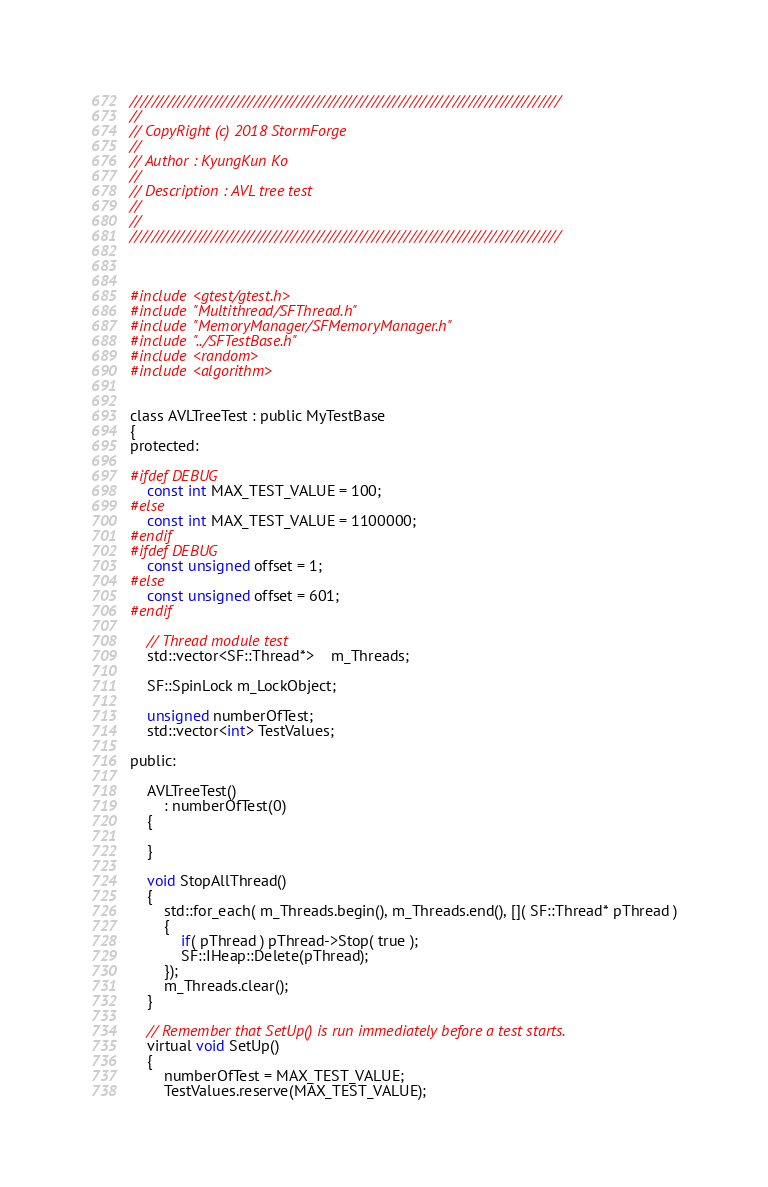<code> <loc_0><loc_0><loc_500><loc_500><_C_>////////////////////////////////////////////////////////////////////////////////
// 
// CopyRight (c) 2018 StormForge
// 
// Author : KyungKun Ko
//
// Description : AVL tree test
//	
//
////////////////////////////////////////////////////////////////////////////////



#include <gtest/gtest.h>
#include "Multithread/SFThread.h"
#include "MemoryManager/SFMemoryManager.h"
#include "../SFTestBase.h"
#include <random>
#include <algorithm>


class AVLTreeTest : public MyTestBase
{
protected:

#ifdef DEBUG
	const int MAX_TEST_VALUE = 100;
#else
	const int MAX_TEST_VALUE = 1100000;
#endif
#ifdef DEBUG
	const unsigned offset = 1;
#else
	const unsigned offset = 601;
#endif

	// Thread module test
	std::vector<SF::Thread*>	m_Threads;

	SF::SpinLock m_LockObject;

	unsigned numberOfTest;
	std::vector<int> TestValues;

public:

	AVLTreeTest()
		: numberOfTest(0)
	{

	}

	void StopAllThread()
	{
		std::for_each( m_Threads.begin(), m_Threads.end(), []( SF::Thread* pThread )
		{
			if( pThread ) pThread->Stop( true );
			SF::IHeap::Delete(pThread);
		});
		m_Threads.clear();
	}

	// Remember that SetUp() is run immediately before a test starts.
	virtual void SetUp()
	{
		numberOfTest = MAX_TEST_VALUE;
		TestValues.reserve(MAX_TEST_VALUE);</code> 